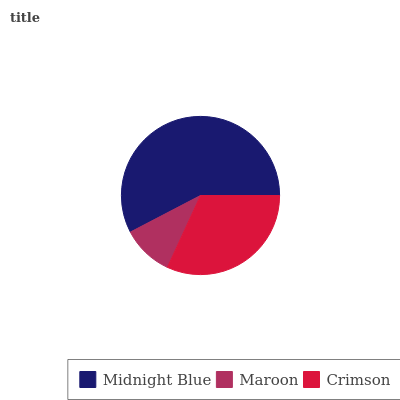Is Maroon the minimum?
Answer yes or no. Yes. Is Midnight Blue the maximum?
Answer yes or no. Yes. Is Crimson the minimum?
Answer yes or no. No. Is Crimson the maximum?
Answer yes or no. No. Is Crimson greater than Maroon?
Answer yes or no. Yes. Is Maroon less than Crimson?
Answer yes or no. Yes. Is Maroon greater than Crimson?
Answer yes or no. No. Is Crimson less than Maroon?
Answer yes or no. No. Is Crimson the high median?
Answer yes or no. Yes. Is Crimson the low median?
Answer yes or no. Yes. Is Maroon the high median?
Answer yes or no. No. Is Midnight Blue the low median?
Answer yes or no. No. 